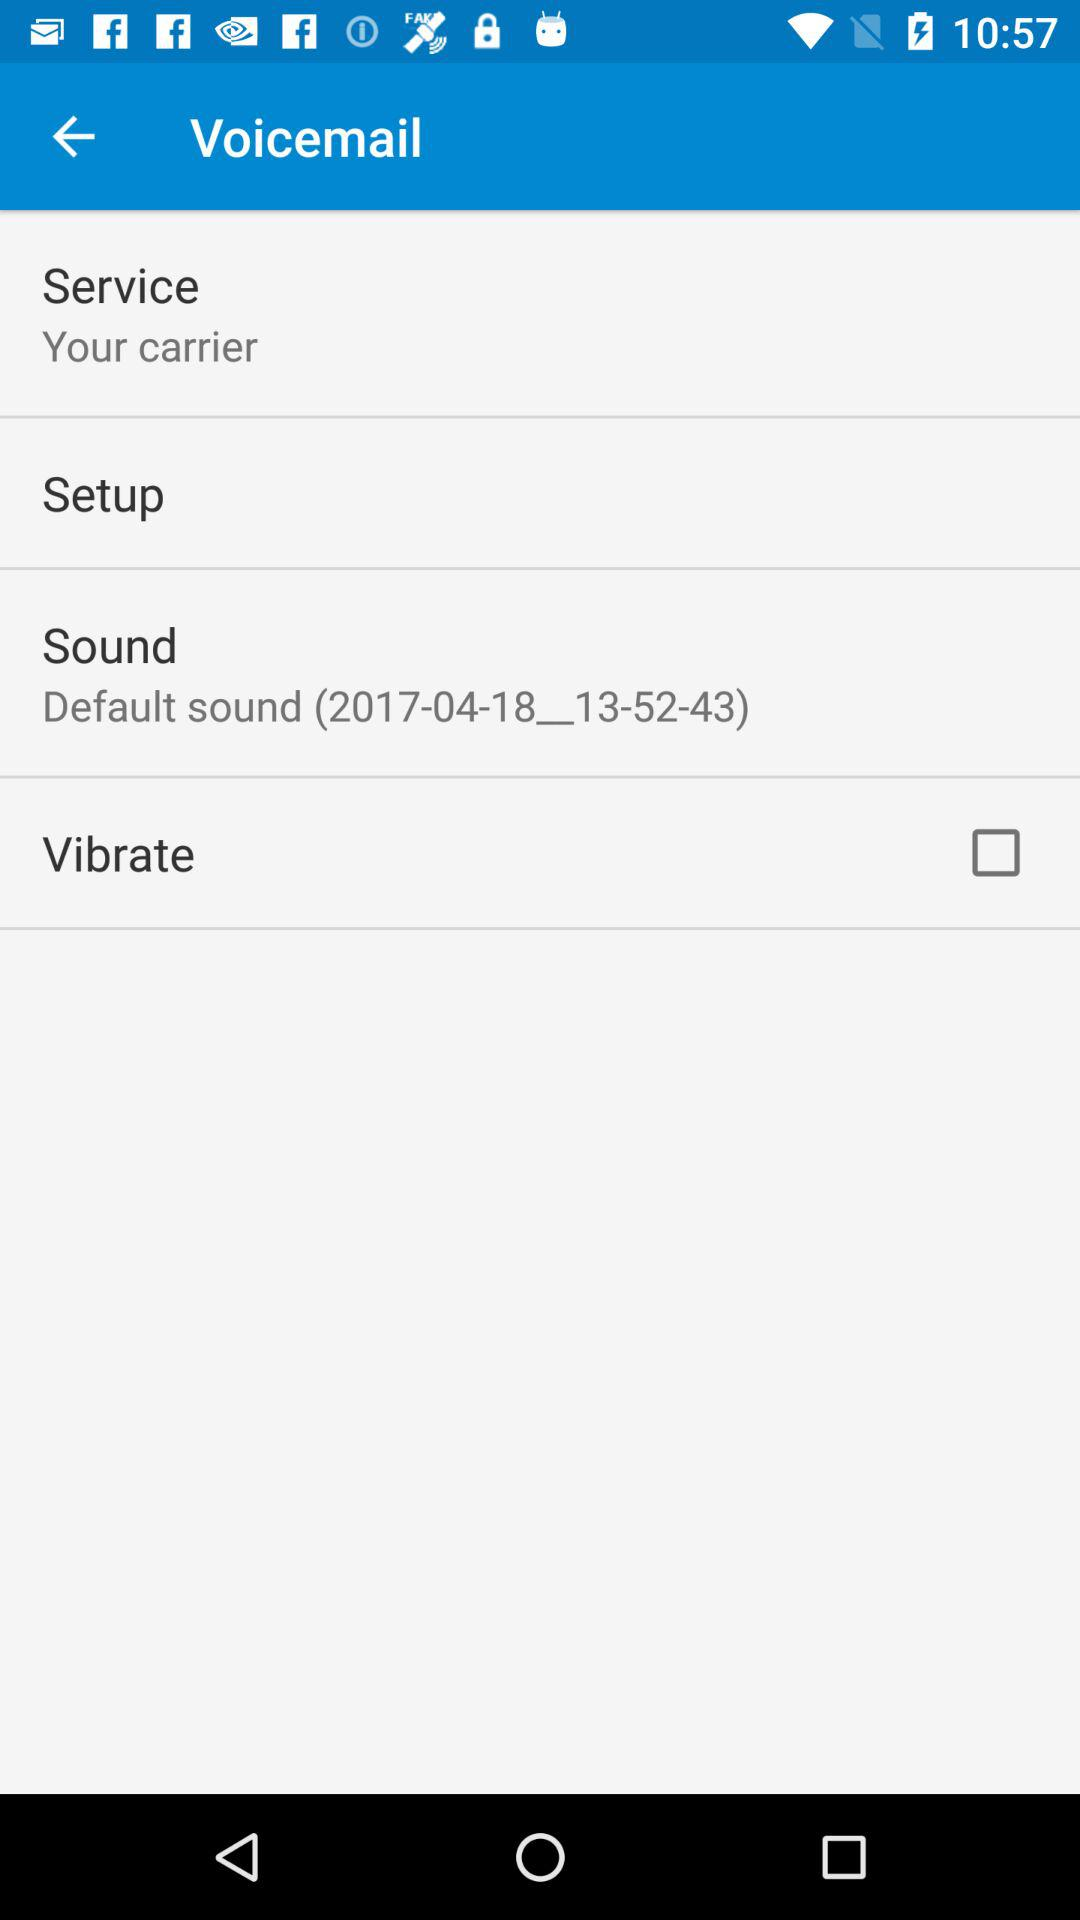Is "Vibrate" checked or unchecked?
Answer the question using a single word or phrase. "Vibrate" is unchecked. 